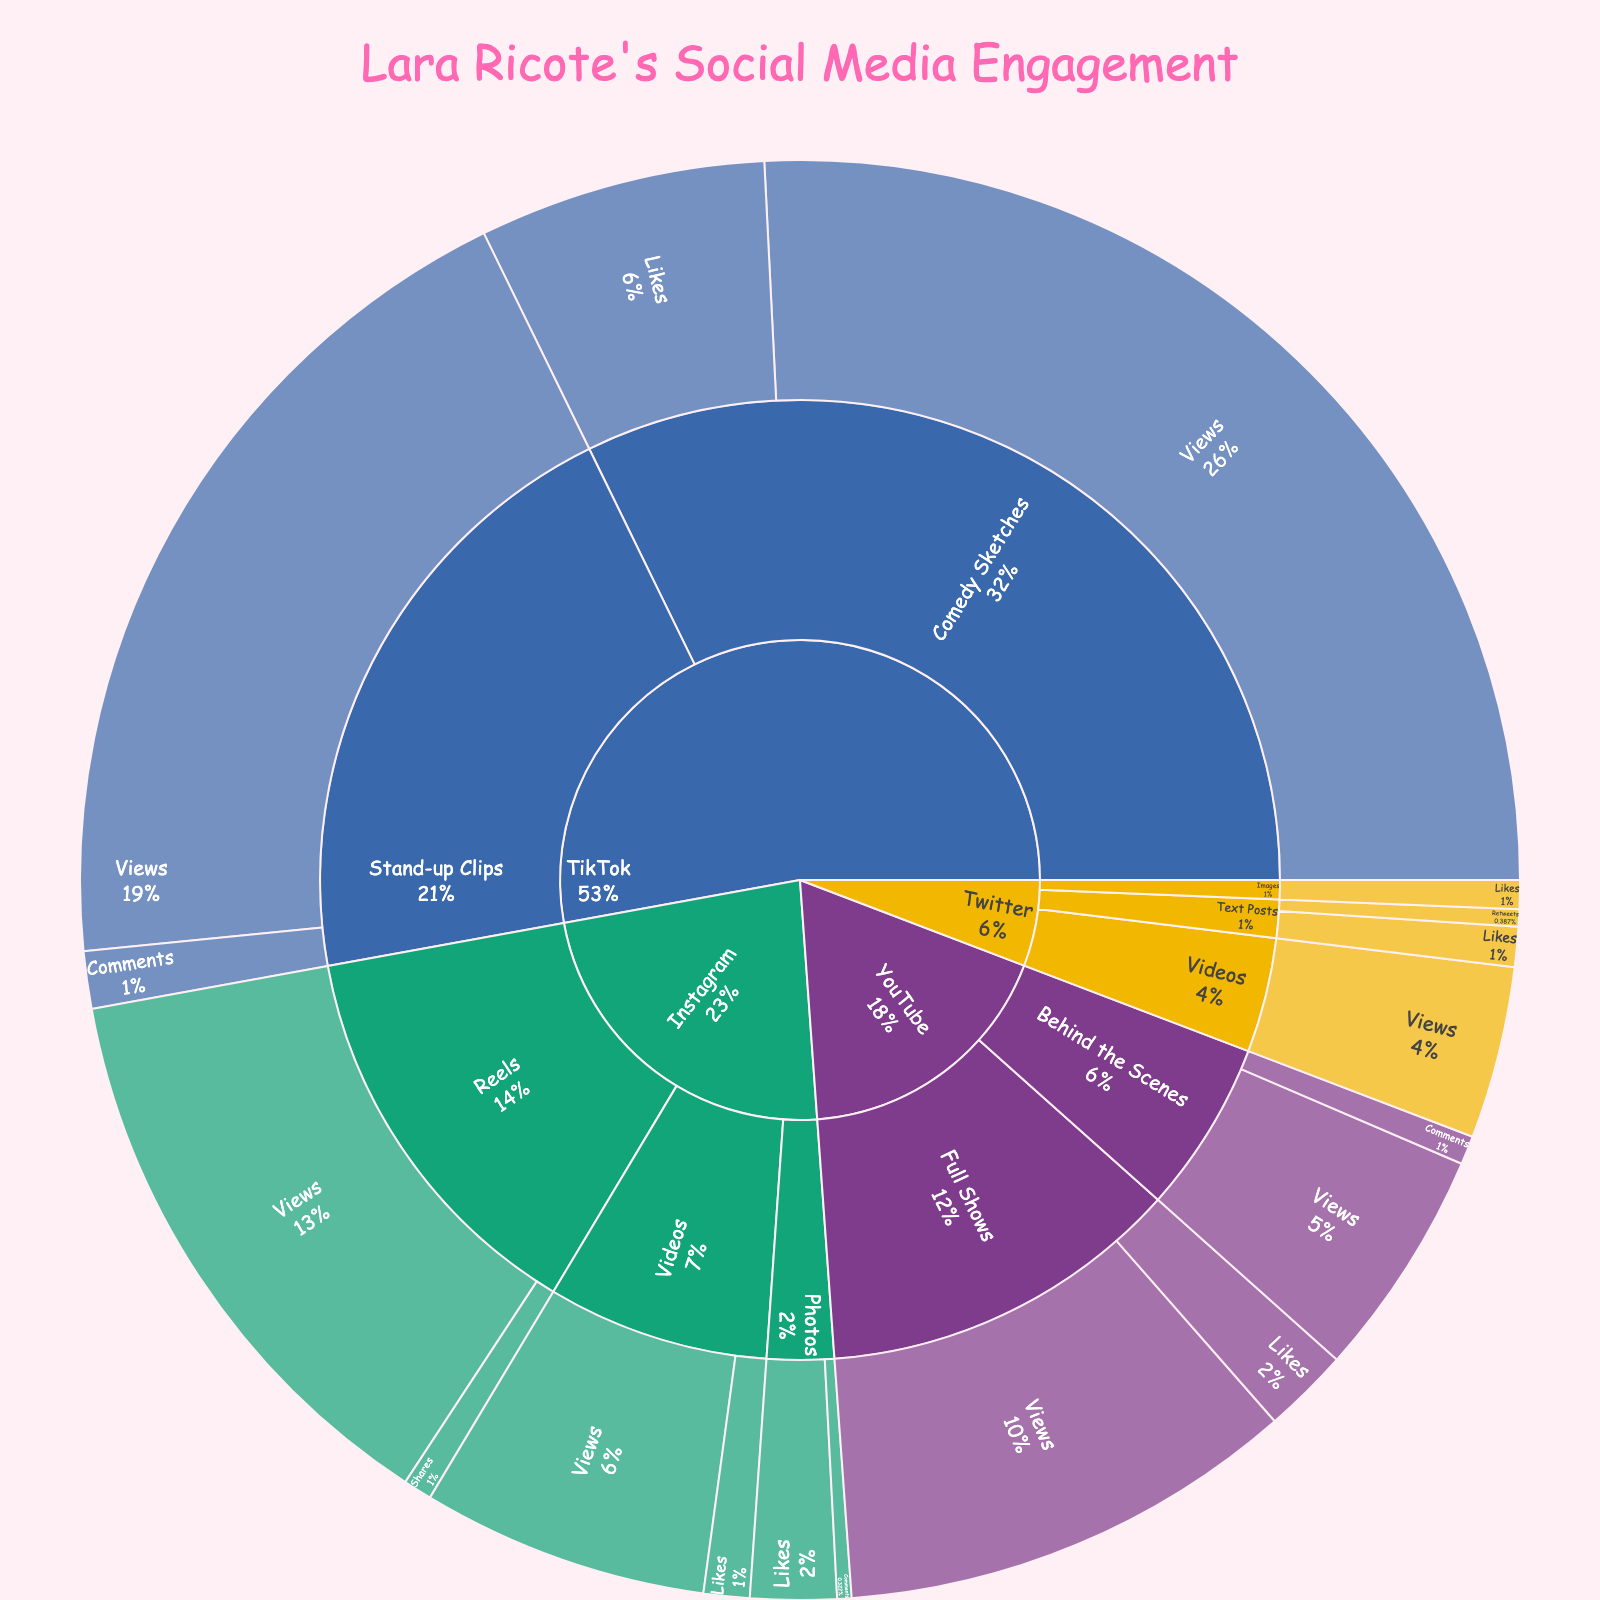What is the title of the plot? The title of the plot is displayed at the top of the figure in a larger font and pink color. The title provided in the code is "Lara Ricote's Social Media Engagement."
Answer: Lara Ricote's Social Media Engagement Which platform has the highest total engagement? To find which platform has the highest total engagement, sum the engagement values for each platform. TikTok has the highest total engagement with 200,000 + 50,000 + 150,000 + 10,000 = 410,000, which is greater than the totals for the other platforms.
Answer: TikTok How many types of content does Lara Ricote share on Instagram? In the figure, Instagram's section is divided into three main categories: Photos, Videos, and Reels. This indicates that there are three types of content.
Answer: 3 Which content type on Instagram has the highest engagement metric, and what is it? Look at the engagement values for each content type under Instagram. Reels have the highest engagement with 100,000 views.
Answer: Reels, 100,000 views What is the total number of views across all platforms? Sum all the engagement values labeled as views: 50,000 + 100,000 + 30,000 + 200,000 + 150,000 + 80,000 + 40,000 = 650,000.
Answer: 650,000 What are the comments on YouTube behind the scenes compared to TikTok stand-up clips? Compare the engagement values for YouTube's behind-the-scenes comments (5,000) and TikTok's stand-up clips comments (10,000). TikTok stand-up clips have more comments.
Answer: TikTok stand-up clips have more comments Which platform has the highest number of likes for a singular content type? Look at the engagement metric values for likes across all platforms and content types. TikTok's comedy sketches have the highest number of likes with 50,000.
Answer: TikTok’s comedy sketches What is the combined total of likes and comments on Instagram photos? Add the likes and comments values for Instagram photos: 15,000 + 2,500 = 17,500.
Answer: 17,500 Compare the number of retweets for Twitter text posts to the number of shares for Instagram reels. Which is higher? Twitter text posts have 3,000 retweets, while Instagram reels have 5,000 shares. Instagram reels have a higher count.
Answer: Instagram reels How many unique engagement metrics are tracked in the plot? Engagement metrics in the data include Likes, Comments, Views, Shares, and Retweets, making it five unique engagement metrics.
Answer: 5 